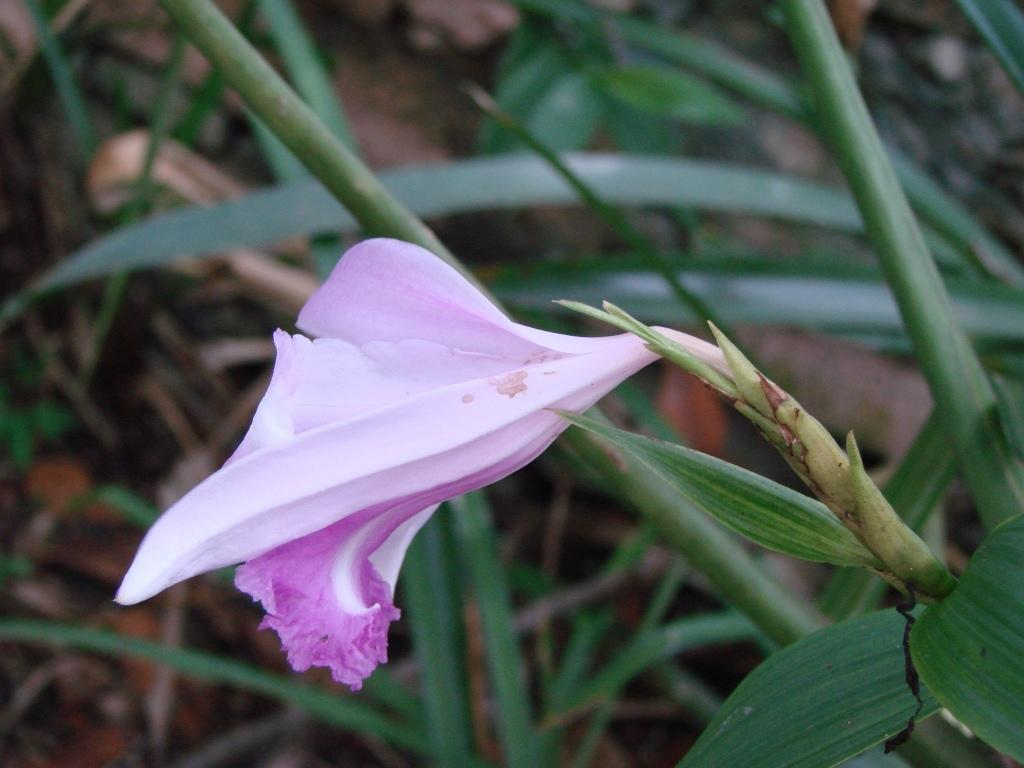What is the main subject of the image? The main subject of the image is a flower on a plant. Are there any other plants visible in the image? Yes, there are other plants surrounding the flower in the image. How many eyes can be seen on the flower in the image? Flowers do not have eyes, so there are no eyes visible on the flower in the image. 